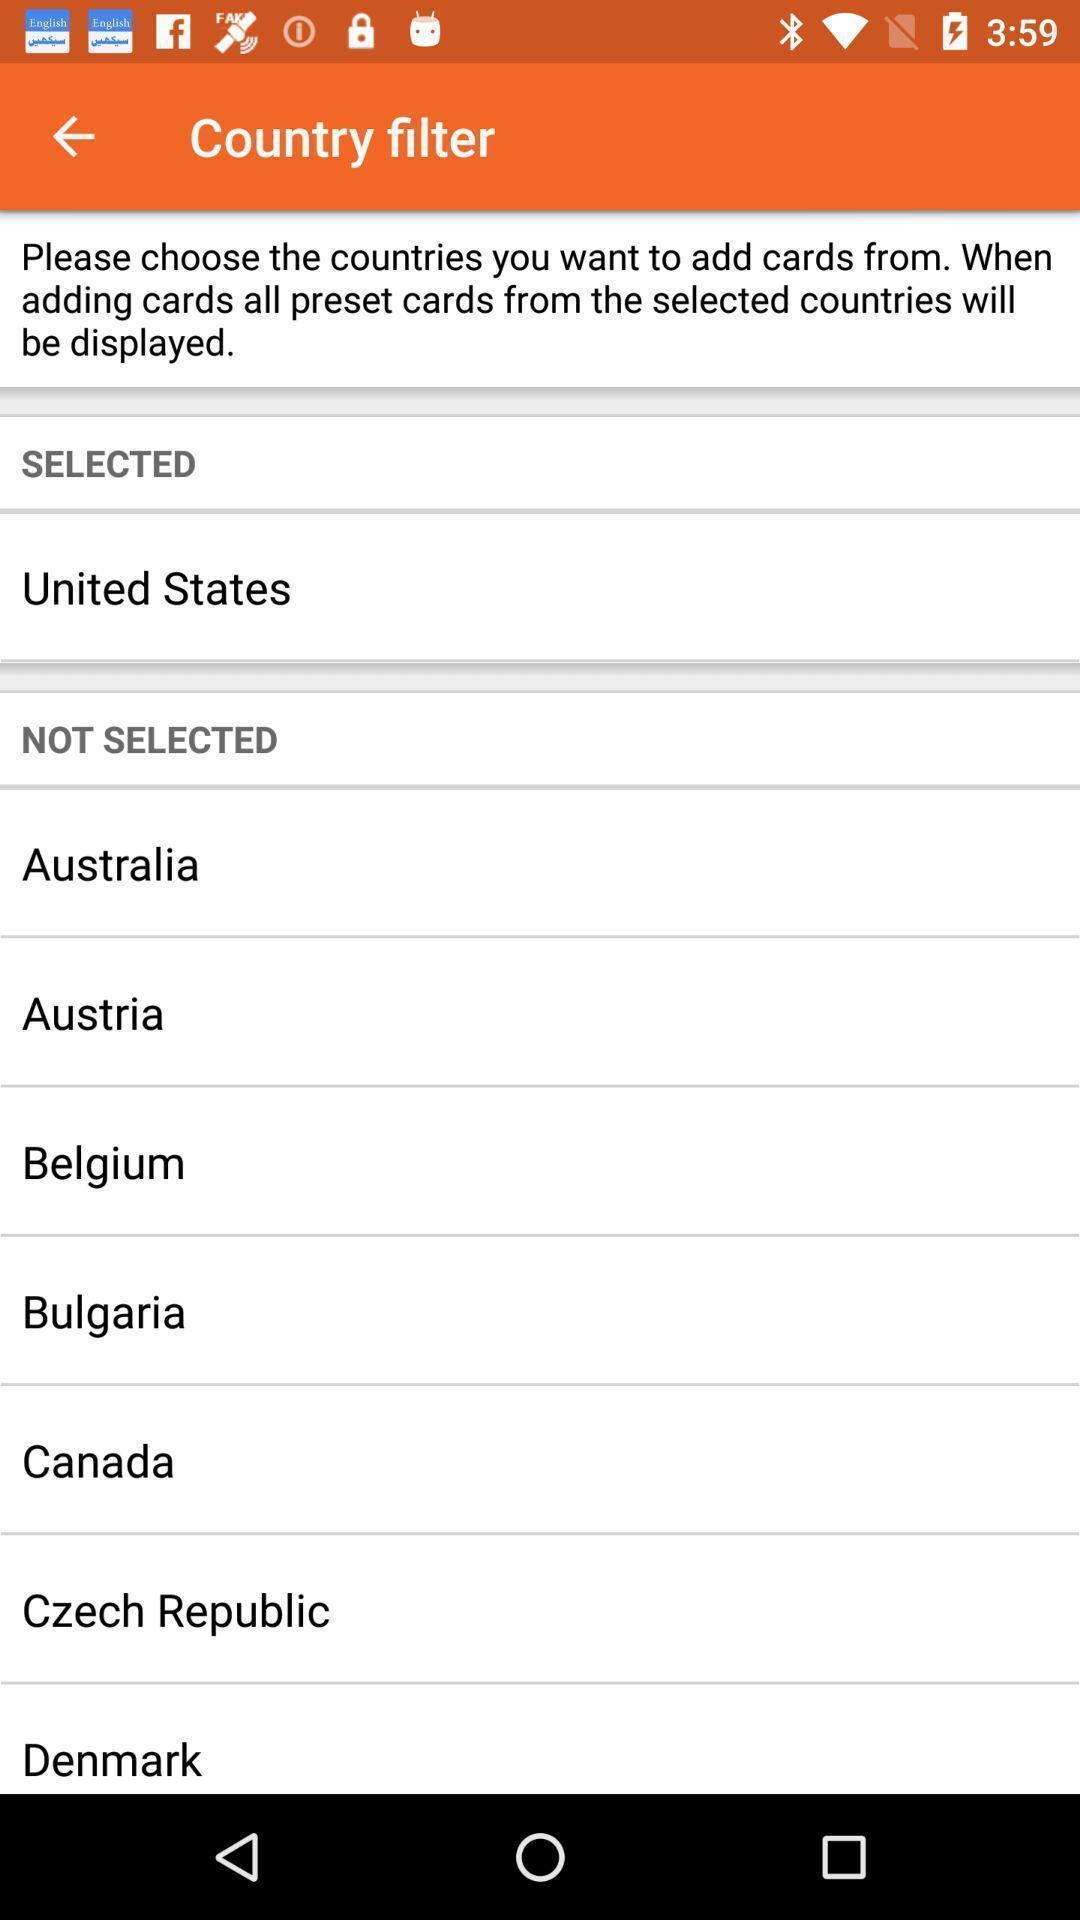Explain the elements present in this screenshot. Screen displaying the country filter options. 